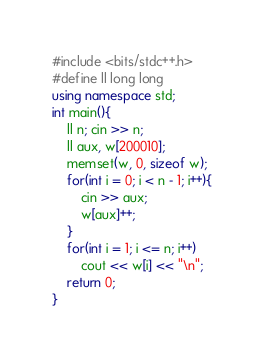<code> <loc_0><loc_0><loc_500><loc_500><_C++_>#include <bits/stdc++.h>
#define ll long long
using namespace std;
int main(){
    ll n; cin >> n;
    ll aux, w[200010];
    memset(w, 0, sizeof w);
    for(int i = 0; i < n - 1; i++){
        cin >> aux;
        w[aux]++;
    }
    for(int i = 1; i <= n; i++)
        cout << w[i] << "\n";
    return 0;
}
</code> 